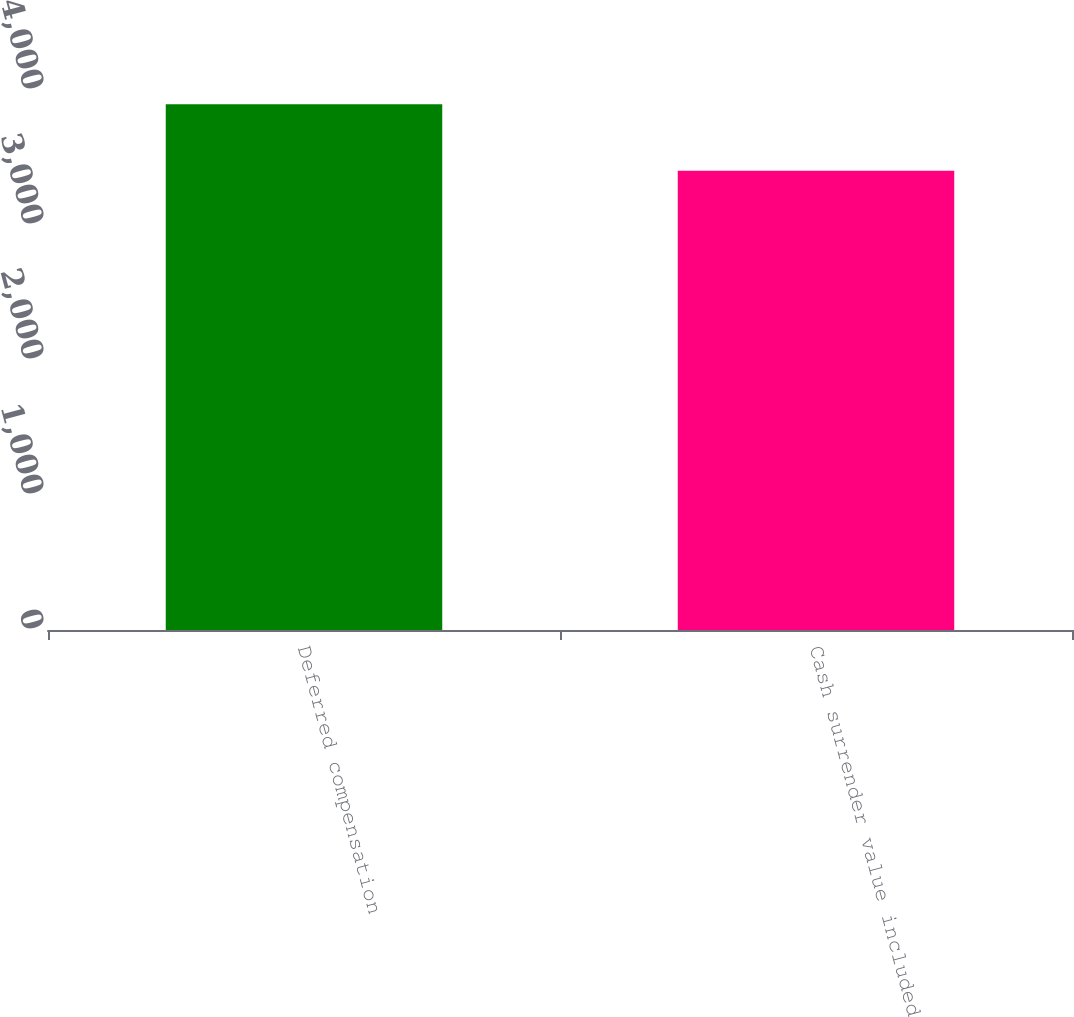Convert chart. <chart><loc_0><loc_0><loc_500><loc_500><bar_chart><fcel>Deferred compensation<fcel>Cash surrender value included<nl><fcel>3894<fcel>3401<nl></chart> 